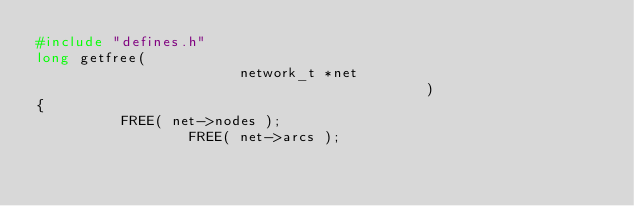Convert code to text. <code><loc_0><loc_0><loc_500><loc_500><_C_>#include "defines.h"
long getfree( 
		                    network_t *net
							                                )   
{  
	        FREE( net->nodes );
			            FREE( net->arcs );</code> 